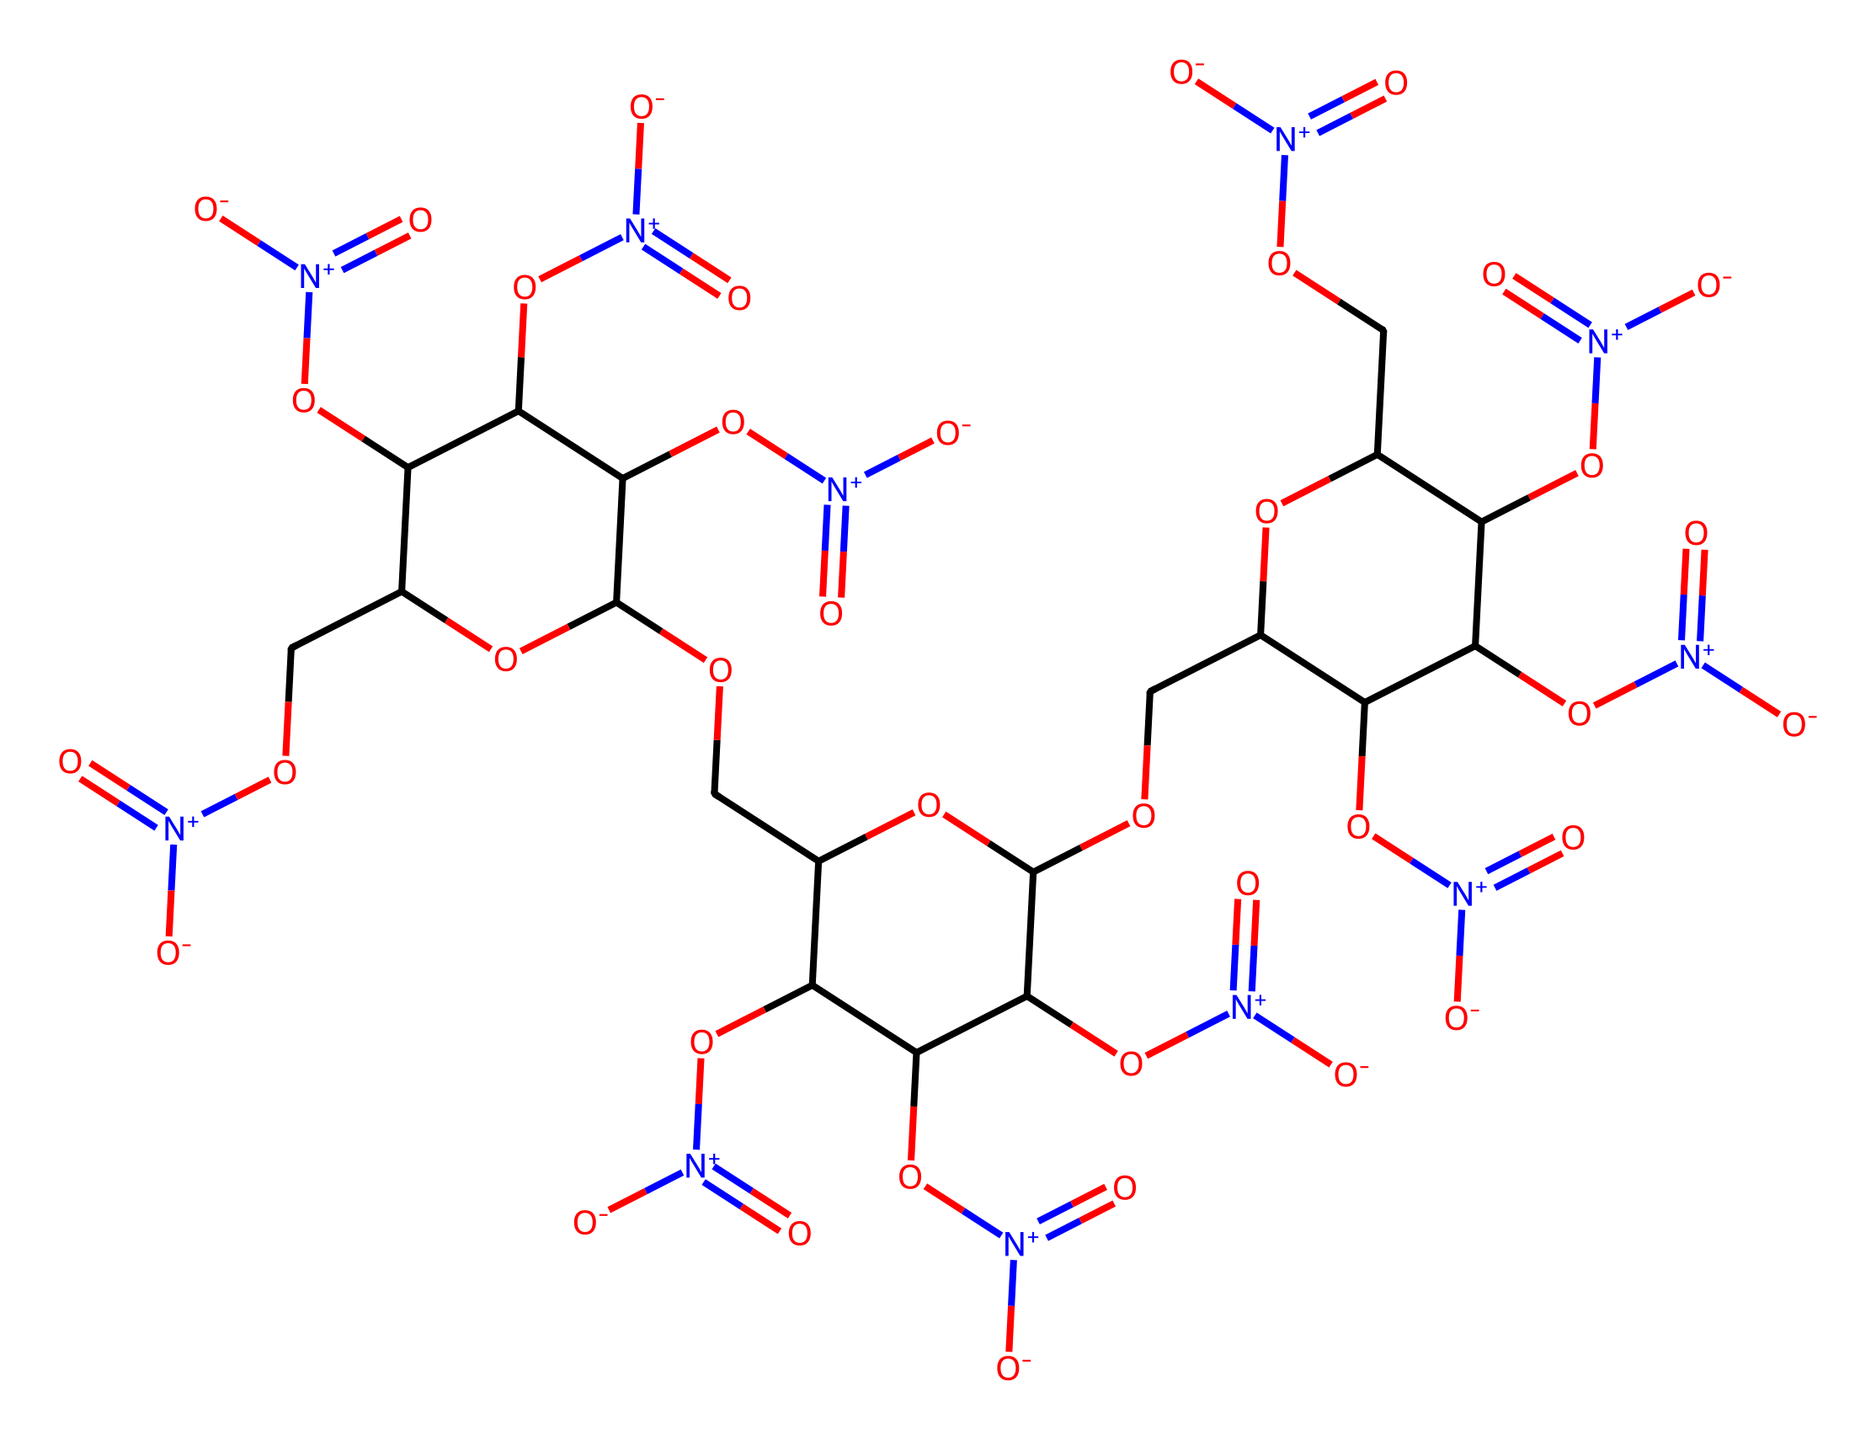What is the total number of oxygen atoms in this molecule? To find the total number of oxygen atoms, I need to count the instances of "O" in the SMILES representation. There are 11 instances of "O."
Answer: 11 How many rings are present in this chemical structure? The structure indicates several cyclic components (rings). By analyzing the SMILES, I can see there are multiple cyclic structures, confirming at least 3 rings are present as indicated by the "C1," "C2," and "C3" notations.
Answer: 3 What type of chemical compound is this, specifically in the context of non-electrolytes? Non-electrolytes are compounds that do not dissociate in solution to produce ions. This compound does not show any ionizable groups in its structure, making it a non-electrolyte.
Answer: non-electrolyte What functional groups are evident in this molecule? Observing the structure, there are several nitro groups (indicated by "N+[]" and attached to oxygen) showing the presence of nitro functional groups, as well as ether linkages represented by (OCC) and hydroxyl groups (-OH).
Answer: nitro groups, ether linkages, hydroxyl groups What is the overall charge of this molecule? By assessing the structure, I can see multiple positively charged nitrogen atoms and corresponding negatively charged oxygens due to the presence of nitro groups. The overall charge balances to zero, indicating that the molecule is neutral.
Answer: neutral 